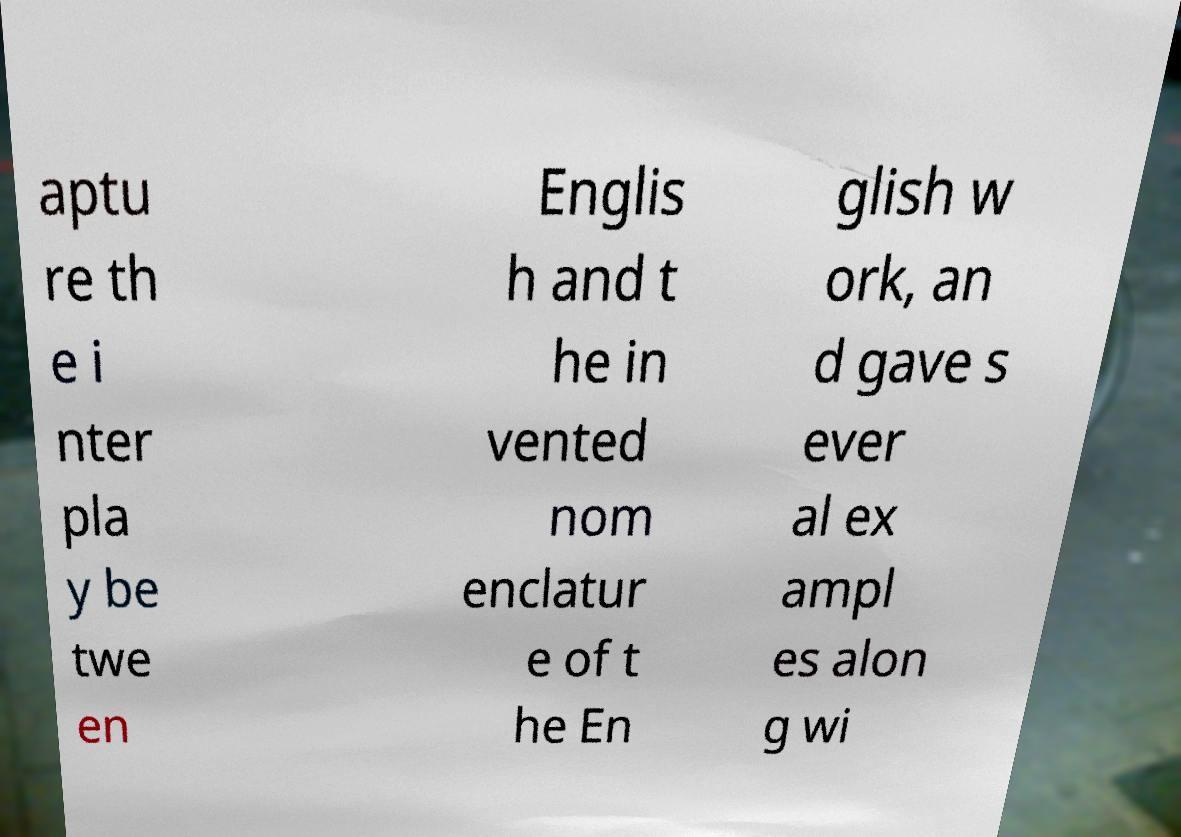I need the written content from this picture converted into text. Can you do that? aptu re th e i nter pla y be twe en Englis h and t he in vented nom enclatur e of t he En glish w ork, an d gave s ever al ex ampl es alon g wi 